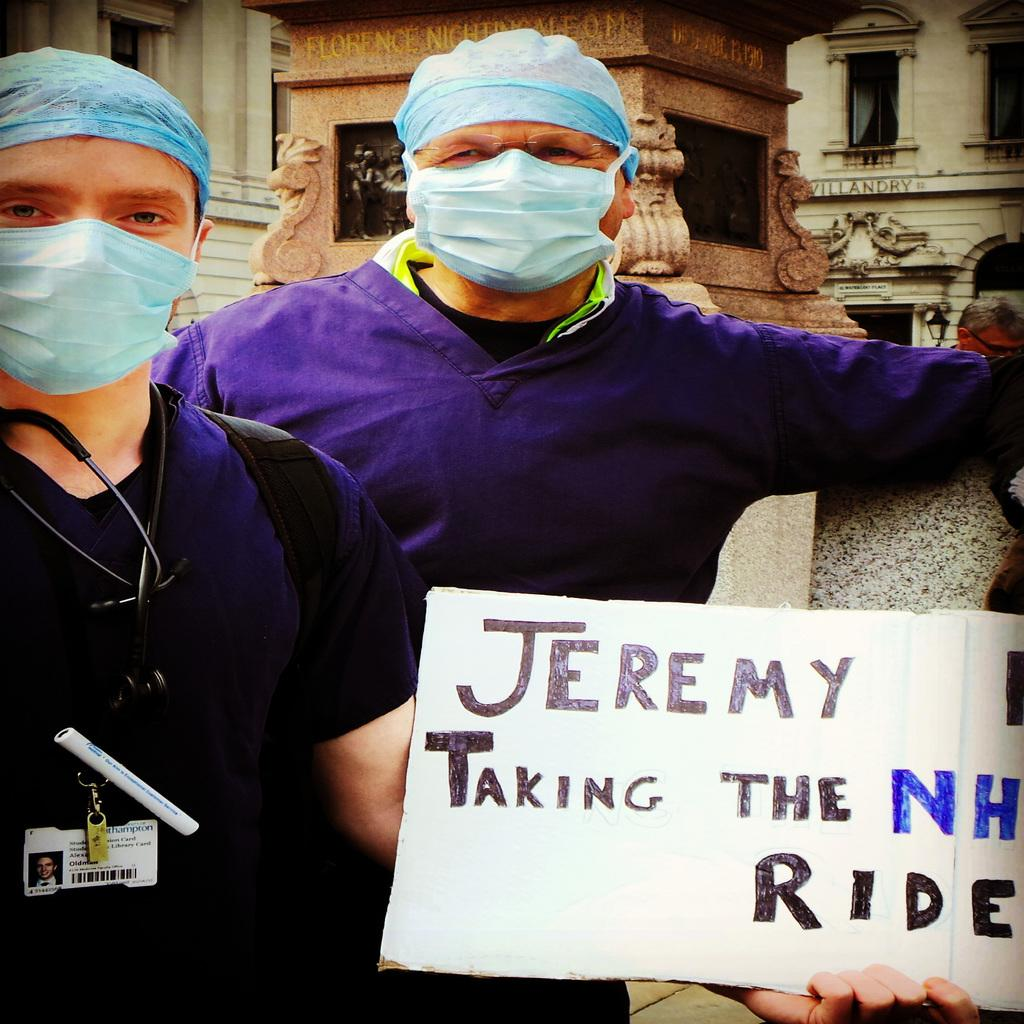How many people are in the image? There are two men in the image. What are the men holding in the image? The men are holding a poster. Where is the poster located in the image? The poster is in the middle of the image. What can be seen in the background of the image? There are buildings in the background of the image. What type of ray is visible in the image? There is no ray present in the image. What day of the week is it in the image? The day of the week cannot be determined from the image. 